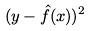<formula> <loc_0><loc_0><loc_500><loc_500>( y - \hat { f } ( x ) ) ^ { 2 }</formula> 